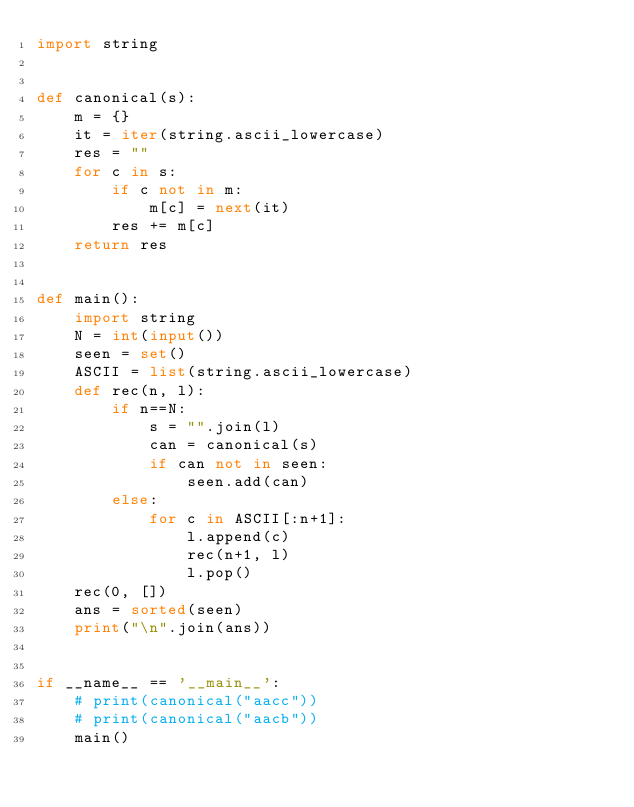Convert code to text. <code><loc_0><loc_0><loc_500><loc_500><_Python_>import string


def canonical(s):
    m = {}
    it = iter(string.ascii_lowercase)
    res = ""
    for c in s:
        if c not in m:
            m[c] = next(it)
        res += m[c]
    return res


def main():
    import string
    N = int(input())
    seen = set()
    ASCII = list(string.ascii_lowercase)
    def rec(n, l):
        if n==N:
            s = "".join(l)
            can = canonical(s)
            if can not in seen:
                seen.add(can)
        else:
            for c in ASCII[:n+1]:
                l.append(c)
                rec(n+1, l)
                l.pop()
    rec(0, [])
    ans = sorted(seen)
    print("\n".join(ans))


if __name__ == '__main__':
    # print(canonical("aacc"))
    # print(canonical("aacb"))
    main()
</code> 